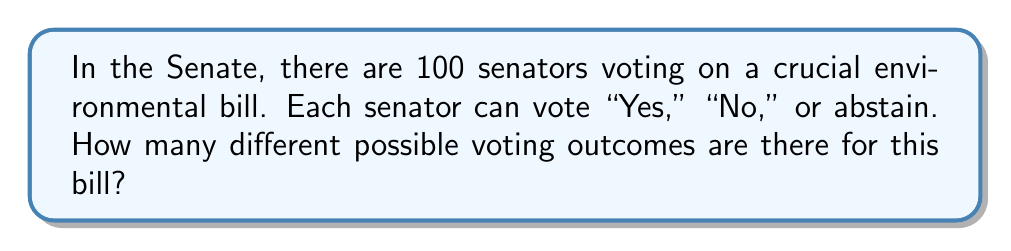What is the answer to this math problem? Let's approach this step-by-step:

1) Each senator has 3 choices: "Yes," "No," or abstain.

2) This is a classic counting problem where we're dealing with independent choices for each senator.

3) When we have independent choices, we multiply the number of options for each choice.

4) In this case, we have 3 choices for each of the 100 senators.

5) Therefore, we can express this mathematically as:

   $$3^{100}$$

6) This is because:
   - The first senator has 3 choices
   - For each of those choices, the second senator has 3 choices
   - For each of those choices, the third senator has 3 choices
   - And so on, for all 100 senators

7) Calculating this number:
   $$3^{100} = 5.15377 \times 10^{47}$$

This is an enormously large number, which makes sense given the vast number of possible combinations when 100 people each have 3 choices.
Answer: $3^{100}$ 